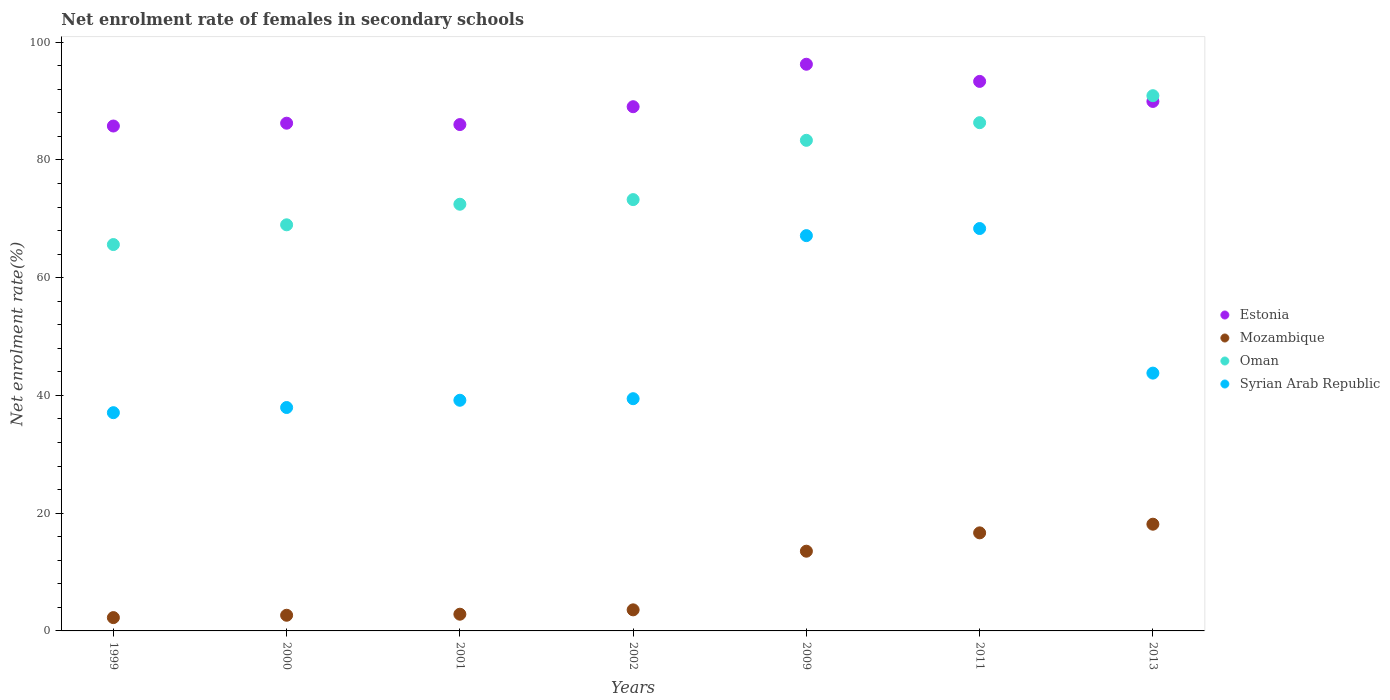Is the number of dotlines equal to the number of legend labels?
Keep it short and to the point. Yes. What is the net enrolment rate of females in secondary schools in Mozambique in 2011?
Offer a very short reply. 16.66. Across all years, what is the maximum net enrolment rate of females in secondary schools in Syrian Arab Republic?
Your answer should be compact. 68.35. Across all years, what is the minimum net enrolment rate of females in secondary schools in Oman?
Keep it short and to the point. 65.63. In which year was the net enrolment rate of females in secondary schools in Oman minimum?
Your answer should be very brief. 1999. What is the total net enrolment rate of females in secondary schools in Mozambique in the graph?
Your answer should be compact. 59.67. What is the difference between the net enrolment rate of females in secondary schools in Mozambique in 2000 and that in 2002?
Make the answer very short. -0.92. What is the difference between the net enrolment rate of females in secondary schools in Syrian Arab Republic in 2000 and the net enrolment rate of females in secondary schools in Mozambique in 2001?
Ensure brevity in your answer.  35.11. What is the average net enrolment rate of females in secondary schools in Estonia per year?
Provide a short and direct response. 89.51. In the year 1999, what is the difference between the net enrolment rate of females in secondary schools in Estonia and net enrolment rate of females in secondary schools in Syrian Arab Republic?
Keep it short and to the point. 48.69. What is the ratio of the net enrolment rate of females in secondary schools in Syrian Arab Republic in 1999 to that in 2002?
Ensure brevity in your answer.  0.94. Is the difference between the net enrolment rate of females in secondary schools in Estonia in 2000 and 2011 greater than the difference between the net enrolment rate of females in secondary schools in Syrian Arab Republic in 2000 and 2011?
Your response must be concise. Yes. What is the difference between the highest and the second highest net enrolment rate of females in secondary schools in Mozambique?
Give a very brief answer. 1.47. What is the difference between the highest and the lowest net enrolment rate of females in secondary schools in Oman?
Provide a short and direct response. 25.29. In how many years, is the net enrolment rate of females in secondary schools in Mozambique greater than the average net enrolment rate of females in secondary schools in Mozambique taken over all years?
Give a very brief answer. 3. Is the sum of the net enrolment rate of females in secondary schools in Mozambique in 2001 and 2009 greater than the maximum net enrolment rate of females in secondary schools in Estonia across all years?
Provide a succinct answer. No. Does the net enrolment rate of females in secondary schools in Mozambique monotonically increase over the years?
Provide a short and direct response. Yes. How many dotlines are there?
Keep it short and to the point. 4. What is the difference between two consecutive major ticks on the Y-axis?
Provide a succinct answer. 20. Does the graph contain any zero values?
Give a very brief answer. No. Does the graph contain grids?
Your response must be concise. No. What is the title of the graph?
Provide a short and direct response. Net enrolment rate of females in secondary schools. Does "Low income" appear as one of the legend labels in the graph?
Provide a succinct answer. No. What is the label or title of the X-axis?
Your response must be concise. Years. What is the label or title of the Y-axis?
Keep it short and to the point. Net enrolment rate(%). What is the Net enrolment rate(%) of Estonia in 1999?
Provide a succinct answer. 85.76. What is the Net enrolment rate(%) in Mozambique in 1999?
Give a very brief answer. 2.26. What is the Net enrolment rate(%) in Oman in 1999?
Give a very brief answer. 65.63. What is the Net enrolment rate(%) of Syrian Arab Republic in 1999?
Give a very brief answer. 37.07. What is the Net enrolment rate(%) of Estonia in 2000?
Give a very brief answer. 86.24. What is the Net enrolment rate(%) in Mozambique in 2000?
Keep it short and to the point. 2.66. What is the Net enrolment rate(%) in Oman in 2000?
Ensure brevity in your answer.  68.98. What is the Net enrolment rate(%) in Syrian Arab Republic in 2000?
Your answer should be very brief. 37.95. What is the Net enrolment rate(%) in Estonia in 2001?
Ensure brevity in your answer.  86.01. What is the Net enrolment rate(%) of Mozambique in 2001?
Your answer should be very brief. 2.84. What is the Net enrolment rate(%) of Oman in 2001?
Your answer should be compact. 72.48. What is the Net enrolment rate(%) of Syrian Arab Republic in 2001?
Your response must be concise. 39.18. What is the Net enrolment rate(%) in Estonia in 2002?
Make the answer very short. 89.04. What is the Net enrolment rate(%) in Mozambique in 2002?
Offer a very short reply. 3.58. What is the Net enrolment rate(%) of Oman in 2002?
Provide a succinct answer. 73.26. What is the Net enrolment rate(%) in Syrian Arab Republic in 2002?
Your answer should be very brief. 39.45. What is the Net enrolment rate(%) of Estonia in 2009?
Offer a very short reply. 96.26. What is the Net enrolment rate(%) in Mozambique in 2009?
Provide a short and direct response. 13.54. What is the Net enrolment rate(%) in Oman in 2009?
Keep it short and to the point. 83.33. What is the Net enrolment rate(%) of Syrian Arab Republic in 2009?
Offer a terse response. 67.14. What is the Net enrolment rate(%) of Estonia in 2011?
Ensure brevity in your answer.  93.34. What is the Net enrolment rate(%) in Mozambique in 2011?
Your response must be concise. 16.66. What is the Net enrolment rate(%) in Oman in 2011?
Ensure brevity in your answer.  86.33. What is the Net enrolment rate(%) of Syrian Arab Republic in 2011?
Your answer should be very brief. 68.35. What is the Net enrolment rate(%) in Estonia in 2013?
Offer a terse response. 89.94. What is the Net enrolment rate(%) in Mozambique in 2013?
Provide a short and direct response. 18.13. What is the Net enrolment rate(%) of Oman in 2013?
Offer a terse response. 90.91. What is the Net enrolment rate(%) in Syrian Arab Republic in 2013?
Ensure brevity in your answer.  43.79. Across all years, what is the maximum Net enrolment rate(%) in Estonia?
Offer a very short reply. 96.26. Across all years, what is the maximum Net enrolment rate(%) in Mozambique?
Give a very brief answer. 18.13. Across all years, what is the maximum Net enrolment rate(%) in Oman?
Your response must be concise. 90.91. Across all years, what is the maximum Net enrolment rate(%) of Syrian Arab Republic?
Give a very brief answer. 68.35. Across all years, what is the minimum Net enrolment rate(%) of Estonia?
Offer a very short reply. 85.76. Across all years, what is the minimum Net enrolment rate(%) in Mozambique?
Your answer should be compact. 2.26. Across all years, what is the minimum Net enrolment rate(%) in Oman?
Ensure brevity in your answer.  65.63. Across all years, what is the minimum Net enrolment rate(%) of Syrian Arab Republic?
Offer a very short reply. 37.07. What is the total Net enrolment rate(%) of Estonia in the graph?
Give a very brief answer. 626.59. What is the total Net enrolment rate(%) in Mozambique in the graph?
Provide a succinct answer. 59.67. What is the total Net enrolment rate(%) in Oman in the graph?
Make the answer very short. 540.92. What is the total Net enrolment rate(%) of Syrian Arab Republic in the graph?
Your answer should be very brief. 332.93. What is the difference between the Net enrolment rate(%) in Estonia in 1999 and that in 2000?
Provide a succinct answer. -0.48. What is the difference between the Net enrolment rate(%) in Mozambique in 1999 and that in 2000?
Your answer should be compact. -0.4. What is the difference between the Net enrolment rate(%) of Oman in 1999 and that in 2000?
Your response must be concise. -3.35. What is the difference between the Net enrolment rate(%) in Syrian Arab Republic in 1999 and that in 2000?
Ensure brevity in your answer.  -0.88. What is the difference between the Net enrolment rate(%) in Estonia in 1999 and that in 2001?
Keep it short and to the point. -0.25. What is the difference between the Net enrolment rate(%) of Mozambique in 1999 and that in 2001?
Provide a short and direct response. -0.58. What is the difference between the Net enrolment rate(%) of Oman in 1999 and that in 2001?
Provide a short and direct response. -6.85. What is the difference between the Net enrolment rate(%) of Syrian Arab Republic in 1999 and that in 2001?
Your answer should be compact. -2.11. What is the difference between the Net enrolment rate(%) in Estonia in 1999 and that in 2002?
Your answer should be very brief. -3.28. What is the difference between the Net enrolment rate(%) in Mozambique in 1999 and that in 2002?
Provide a short and direct response. -1.32. What is the difference between the Net enrolment rate(%) in Oman in 1999 and that in 2002?
Offer a very short reply. -7.64. What is the difference between the Net enrolment rate(%) of Syrian Arab Republic in 1999 and that in 2002?
Offer a terse response. -2.38. What is the difference between the Net enrolment rate(%) in Estonia in 1999 and that in 2009?
Your response must be concise. -10.49. What is the difference between the Net enrolment rate(%) in Mozambique in 1999 and that in 2009?
Provide a succinct answer. -11.28. What is the difference between the Net enrolment rate(%) of Oman in 1999 and that in 2009?
Your answer should be very brief. -17.71. What is the difference between the Net enrolment rate(%) of Syrian Arab Republic in 1999 and that in 2009?
Keep it short and to the point. -30.07. What is the difference between the Net enrolment rate(%) in Estonia in 1999 and that in 2011?
Make the answer very short. -7.58. What is the difference between the Net enrolment rate(%) of Mozambique in 1999 and that in 2011?
Your response must be concise. -14.4. What is the difference between the Net enrolment rate(%) of Oman in 1999 and that in 2011?
Keep it short and to the point. -20.7. What is the difference between the Net enrolment rate(%) of Syrian Arab Republic in 1999 and that in 2011?
Ensure brevity in your answer.  -31.28. What is the difference between the Net enrolment rate(%) in Estonia in 1999 and that in 2013?
Offer a terse response. -4.17. What is the difference between the Net enrolment rate(%) in Mozambique in 1999 and that in 2013?
Provide a succinct answer. -15.87. What is the difference between the Net enrolment rate(%) in Oman in 1999 and that in 2013?
Offer a terse response. -25.29. What is the difference between the Net enrolment rate(%) of Syrian Arab Republic in 1999 and that in 2013?
Make the answer very short. -6.72. What is the difference between the Net enrolment rate(%) of Estonia in 2000 and that in 2001?
Keep it short and to the point. 0.23. What is the difference between the Net enrolment rate(%) in Mozambique in 2000 and that in 2001?
Ensure brevity in your answer.  -0.18. What is the difference between the Net enrolment rate(%) in Oman in 2000 and that in 2001?
Provide a succinct answer. -3.49. What is the difference between the Net enrolment rate(%) in Syrian Arab Republic in 2000 and that in 2001?
Your answer should be very brief. -1.23. What is the difference between the Net enrolment rate(%) in Estonia in 2000 and that in 2002?
Offer a very short reply. -2.8. What is the difference between the Net enrolment rate(%) in Mozambique in 2000 and that in 2002?
Ensure brevity in your answer.  -0.92. What is the difference between the Net enrolment rate(%) of Oman in 2000 and that in 2002?
Make the answer very short. -4.28. What is the difference between the Net enrolment rate(%) of Syrian Arab Republic in 2000 and that in 2002?
Keep it short and to the point. -1.5. What is the difference between the Net enrolment rate(%) of Estonia in 2000 and that in 2009?
Your answer should be very brief. -10.01. What is the difference between the Net enrolment rate(%) of Mozambique in 2000 and that in 2009?
Offer a terse response. -10.88. What is the difference between the Net enrolment rate(%) of Oman in 2000 and that in 2009?
Your response must be concise. -14.35. What is the difference between the Net enrolment rate(%) of Syrian Arab Republic in 2000 and that in 2009?
Provide a succinct answer. -29.2. What is the difference between the Net enrolment rate(%) in Estonia in 2000 and that in 2011?
Your answer should be very brief. -7.1. What is the difference between the Net enrolment rate(%) of Mozambique in 2000 and that in 2011?
Make the answer very short. -14. What is the difference between the Net enrolment rate(%) in Oman in 2000 and that in 2011?
Keep it short and to the point. -17.35. What is the difference between the Net enrolment rate(%) in Syrian Arab Republic in 2000 and that in 2011?
Provide a succinct answer. -30.4. What is the difference between the Net enrolment rate(%) of Estonia in 2000 and that in 2013?
Offer a terse response. -3.69. What is the difference between the Net enrolment rate(%) in Mozambique in 2000 and that in 2013?
Your response must be concise. -15.47. What is the difference between the Net enrolment rate(%) of Oman in 2000 and that in 2013?
Offer a very short reply. -21.93. What is the difference between the Net enrolment rate(%) of Syrian Arab Republic in 2000 and that in 2013?
Offer a terse response. -5.84. What is the difference between the Net enrolment rate(%) in Estonia in 2001 and that in 2002?
Offer a very short reply. -3.03. What is the difference between the Net enrolment rate(%) in Mozambique in 2001 and that in 2002?
Provide a short and direct response. -0.74. What is the difference between the Net enrolment rate(%) of Oman in 2001 and that in 2002?
Your response must be concise. -0.79. What is the difference between the Net enrolment rate(%) in Syrian Arab Republic in 2001 and that in 2002?
Your response must be concise. -0.27. What is the difference between the Net enrolment rate(%) in Estonia in 2001 and that in 2009?
Your answer should be compact. -10.25. What is the difference between the Net enrolment rate(%) in Mozambique in 2001 and that in 2009?
Ensure brevity in your answer.  -10.7. What is the difference between the Net enrolment rate(%) in Oman in 2001 and that in 2009?
Your response must be concise. -10.86. What is the difference between the Net enrolment rate(%) in Syrian Arab Republic in 2001 and that in 2009?
Make the answer very short. -27.97. What is the difference between the Net enrolment rate(%) in Estonia in 2001 and that in 2011?
Offer a very short reply. -7.33. What is the difference between the Net enrolment rate(%) of Mozambique in 2001 and that in 2011?
Offer a very short reply. -13.82. What is the difference between the Net enrolment rate(%) in Oman in 2001 and that in 2011?
Your answer should be very brief. -13.85. What is the difference between the Net enrolment rate(%) in Syrian Arab Republic in 2001 and that in 2011?
Your answer should be compact. -29.17. What is the difference between the Net enrolment rate(%) of Estonia in 2001 and that in 2013?
Provide a succinct answer. -3.93. What is the difference between the Net enrolment rate(%) of Mozambique in 2001 and that in 2013?
Make the answer very short. -15.29. What is the difference between the Net enrolment rate(%) of Oman in 2001 and that in 2013?
Provide a short and direct response. -18.44. What is the difference between the Net enrolment rate(%) of Syrian Arab Republic in 2001 and that in 2013?
Ensure brevity in your answer.  -4.61. What is the difference between the Net enrolment rate(%) in Estonia in 2002 and that in 2009?
Provide a short and direct response. -7.21. What is the difference between the Net enrolment rate(%) in Mozambique in 2002 and that in 2009?
Provide a succinct answer. -9.96. What is the difference between the Net enrolment rate(%) in Oman in 2002 and that in 2009?
Your response must be concise. -10.07. What is the difference between the Net enrolment rate(%) in Syrian Arab Republic in 2002 and that in 2009?
Your answer should be compact. -27.7. What is the difference between the Net enrolment rate(%) in Estonia in 2002 and that in 2011?
Keep it short and to the point. -4.3. What is the difference between the Net enrolment rate(%) of Mozambique in 2002 and that in 2011?
Provide a succinct answer. -13.08. What is the difference between the Net enrolment rate(%) of Oman in 2002 and that in 2011?
Provide a succinct answer. -13.07. What is the difference between the Net enrolment rate(%) in Syrian Arab Republic in 2002 and that in 2011?
Provide a short and direct response. -28.9. What is the difference between the Net enrolment rate(%) in Estonia in 2002 and that in 2013?
Provide a short and direct response. -0.89. What is the difference between the Net enrolment rate(%) in Mozambique in 2002 and that in 2013?
Provide a short and direct response. -14.55. What is the difference between the Net enrolment rate(%) of Oman in 2002 and that in 2013?
Your answer should be very brief. -17.65. What is the difference between the Net enrolment rate(%) of Syrian Arab Republic in 2002 and that in 2013?
Your response must be concise. -4.34. What is the difference between the Net enrolment rate(%) in Estonia in 2009 and that in 2011?
Your answer should be compact. 2.91. What is the difference between the Net enrolment rate(%) in Mozambique in 2009 and that in 2011?
Keep it short and to the point. -3.12. What is the difference between the Net enrolment rate(%) of Oman in 2009 and that in 2011?
Your answer should be compact. -3. What is the difference between the Net enrolment rate(%) of Syrian Arab Republic in 2009 and that in 2011?
Keep it short and to the point. -1.21. What is the difference between the Net enrolment rate(%) of Estonia in 2009 and that in 2013?
Provide a succinct answer. 6.32. What is the difference between the Net enrolment rate(%) of Mozambique in 2009 and that in 2013?
Make the answer very short. -4.59. What is the difference between the Net enrolment rate(%) in Oman in 2009 and that in 2013?
Offer a terse response. -7.58. What is the difference between the Net enrolment rate(%) in Syrian Arab Republic in 2009 and that in 2013?
Provide a succinct answer. 23.35. What is the difference between the Net enrolment rate(%) in Estonia in 2011 and that in 2013?
Provide a short and direct response. 3.4. What is the difference between the Net enrolment rate(%) of Mozambique in 2011 and that in 2013?
Offer a very short reply. -1.47. What is the difference between the Net enrolment rate(%) in Oman in 2011 and that in 2013?
Your response must be concise. -4.58. What is the difference between the Net enrolment rate(%) in Syrian Arab Republic in 2011 and that in 2013?
Offer a very short reply. 24.56. What is the difference between the Net enrolment rate(%) of Estonia in 1999 and the Net enrolment rate(%) of Mozambique in 2000?
Your response must be concise. 83.1. What is the difference between the Net enrolment rate(%) in Estonia in 1999 and the Net enrolment rate(%) in Oman in 2000?
Provide a succinct answer. 16.78. What is the difference between the Net enrolment rate(%) in Estonia in 1999 and the Net enrolment rate(%) in Syrian Arab Republic in 2000?
Provide a short and direct response. 47.82. What is the difference between the Net enrolment rate(%) in Mozambique in 1999 and the Net enrolment rate(%) in Oman in 2000?
Your response must be concise. -66.72. What is the difference between the Net enrolment rate(%) of Mozambique in 1999 and the Net enrolment rate(%) of Syrian Arab Republic in 2000?
Give a very brief answer. -35.69. What is the difference between the Net enrolment rate(%) in Oman in 1999 and the Net enrolment rate(%) in Syrian Arab Republic in 2000?
Keep it short and to the point. 27.68. What is the difference between the Net enrolment rate(%) in Estonia in 1999 and the Net enrolment rate(%) in Mozambique in 2001?
Keep it short and to the point. 82.92. What is the difference between the Net enrolment rate(%) in Estonia in 1999 and the Net enrolment rate(%) in Oman in 2001?
Offer a terse response. 13.29. What is the difference between the Net enrolment rate(%) in Estonia in 1999 and the Net enrolment rate(%) in Syrian Arab Republic in 2001?
Keep it short and to the point. 46.58. What is the difference between the Net enrolment rate(%) in Mozambique in 1999 and the Net enrolment rate(%) in Oman in 2001?
Your answer should be very brief. -70.21. What is the difference between the Net enrolment rate(%) in Mozambique in 1999 and the Net enrolment rate(%) in Syrian Arab Republic in 2001?
Provide a short and direct response. -36.92. What is the difference between the Net enrolment rate(%) of Oman in 1999 and the Net enrolment rate(%) of Syrian Arab Republic in 2001?
Offer a terse response. 26.45. What is the difference between the Net enrolment rate(%) in Estonia in 1999 and the Net enrolment rate(%) in Mozambique in 2002?
Provide a short and direct response. 82.18. What is the difference between the Net enrolment rate(%) of Estonia in 1999 and the Net enrolment rate(%) of Oman in 2002?
Give a very brief answer. 12.5. What is the difference between the Net enrolment rate(%) in Estonia in 1999 and the Net enrolment rate(%) in Syrian Arab Republic in 2002?
Your response must be concise. 46.32. What is the difference between the Net enrolment rate(%) of Mozambique in 1999 and the Net enrolment rate(%) of Oman in 2002?
Offer a very short reply. -71. What is the difference between the Net enrolment rate(%) in Mozambique in 1999 and the Net enrolment rate(%) in Syrian Arab Republic in 2002?
Provide a short and direct response. -37.18. What is the difference between the Net enrolment rate(%) of Oman in 1999 and the Net enrolment rate(%) of Syrian Arab Republic in 2002?
Give a very brief answer. 26.18. What is the difference between the Net enrolment rate(%) of Estonia in 1999 and the Net enrolment rate(%) of Mozambique in 2009?
Offer a very short reply. 72.22. What is the difference between the Net enrolment rate(%) of Estonia in 1999 and the Net enrolment rate(%) of Oman in 2009?
Give a very brief answer. 2.43. What is the difference between the Net enrolment rate(%) in Estonia in 1999 and the Net enrolment rate(%) in Syrian Arab Republic in 2009?
Your answer should be compact. 18.62. What is the difference between the Net enrolment rate(%) in Mozambique in 1999 and the Net enrolment rate(%) in Oman in 2009?
Offer a very short reply. -81.07. What is the difference between the Net enrolment rate(%) in Mozambique in 1999 and the Net enrolment rate(%) in Syrian Arab Republic in 2009?
Give a very brief answer. -64.88. What is the difference between the Net enrolment rate(%) of Oman in 1999 and the Net enrolment rate(%) of Syrian Arab Republic in 2009?
Ensure brevity in your answer.  -1.52. What is the difference between the Net enrolment rate(%) of Estonia in 1999 and the Net enrolment rate(%) of Mozambique in 2011?
Keep it short and to the point. 69.11. What is the difference between the Net enrolment rate(%) in Estonia in 1999 and the Net enrolment rate(%) in Oman in 2011?
Your answer should be compact. -0.57. What is the difference between the Net enrolment rate(%) of Estonia in 1999 and the Net enrolment rate(%) of Syrian Arab Republic in 2011?
Your answer should be very brief. 17.41. What is the difference between the Net enrolment rate(%) of Mozambique in 1999 and the Net enrolment rate(%) of Oman in 2011?
Give a very brief answer. -84.07. What is the difference between the Net enrolment rate(%) in Mozambique in 1999 and the Net enrolment rate(%) in Syrian Arab Republic in 2011?
Your answer should be compact. -66.09. What is the difference between the Net enrolment rate(%) in Oman in 1999 and the Net enrolment rate(%) in Syrian Arab Republic in 2011?
Offer a terse response. -2.72. What is the difference between the Net enrolment rate(%) of Estonia in 1999 and the Net enrolment rate(%) of Mozambique in 2013?
Keep it short and to the point. 67.64. What is the difference between the Net enrolment rate(%) in Estonia in 1999 and the Net enrolment rate(%) in Oman in 2013?
Give a very brief answer. -5.15. What is the difference between the Net enrolment rate(%) of Estonia in 1999 and the Net enrolment rate(%) of Syrian Arab Republic in 2013?
Your answer should be very brief. 41.97. What is the difference between the Net enrolment rate(%) of Mozambique in 1999 and the Net enrolment rate(%) of Oman in 2013?
Your answer should be compact. -88.65. What is the difference between the Net enrolment rate(%) of Mozambique in 1999 and the Net enrolment rate(%) of Syrian Arab Republic in 2013?
Provide a succinct answer. -41.53. What is the difference between the Net enrolment rate(%) in Oman in 1999 and the Net enrolment rate(%) in Syrian Arab Republic in 2013?
Ensure brevity in your answer.  21.84. What is the difference between the Net enrolment rate(%) in Estonia in 2000 and the Net enrolment rate(%) in Mozambique in 2001?
Make the answer very short. 83.4. What is the difference between the Net enrolment rate(%) in Estonia in 2000 and the Net enrolment rate(%) in Oman in 2001?
Provide a short and direct response. 13.77. What is the difference between the Net enrolment rate(%) in Estonia in 2000 and the Net enrolment rate(%) in Syrian Arab Republic in 2001?
Your answer should be compact. 47.06. What is the difference between the Net enrolment rate(%) of Mozambique in 2000 and the Net enrolment rate(%) of Oman in 2001?
Ensure brevity in your answer.  -69.81. What is the difference between the Net enrolment rate(%) in Mozambique in 2000 and the Net enrolment rate(%) in Syrian Arab Republic in 2001?
Give a very brief answer. -36.52. What is the difference between the Net enrolment rate(%) in Oman in 2000 and the Net enrolment rate(%) in Syrian Arab Republic in 2001?
Give a very brief answer. 29.8. What is the difference between the Net enrolment rate(%) of Estonia in 2000 and the Net enrolment rate(%) of Mozambique in 2002?
Your response must be concise. 82.66. What is the difference between the Net enrolment rate(%) in Estonia in 2000 and the Net enrolment rate(%) in Oman in 2002?
Your answer should be very brief. 12.98. What is the difference between the Net enrolment rate(%) of Estonia in 2000 and the Net enrolment rate(%) of Syrian Arab Republic in 2002?
Your answer should be compact. 46.8. What is the difference between the Net enrolment rate(%) in Mozambique in 2000 and the Net enrolment rate(%) in Oman in 2002?
Your answer should be very brief. -70.6. What is the difference between the Net enrolment rate(%) in Mozambique in 2000 and the Net enrolment rate(%) in Syrian Arab Republic in 2002?
Give a very brief answer. -36.78. What is the difference between the Net enrolment rate(%) in Oman in 2000 and the Net enrolment rate(%) in Syrian Arab Republic in 2002?
Provide a short and direct response. 29.54. What is the difference between the Net enrolment rate(%) of Estonia in 2000 and the Net enrolment rate(%) of Mozambique in 2009?
Ensure brevity in your answer.  72.7. What is the difference between the Net enrolment rate(%) of Estonia in 2000 and the Net enrolment rate(%) of Oman in 2009?
Your answer should be compact. 2.91. What is the difference between the Net enrolment rate(%) of Estonia in 2000 and the Net enrolment rate(%) of Syrian Arab Republic in 2009?
Provide a succinct answer. 19.1. What is the difference between the Net enrolment rate(%) of Mozambique in 2000 and the Net enrolment rate(%) of Oman in 2009?
Offer a very short reply. -80.67. What is the difference between the Net enrolment rate(%) in Mozambique in 2000 and the Net enrolment rate(%) in Syrian Arab Republic in 2009?
Give a very brief answer. -64.48. What is the difference between the Net enrolment rate(%) of Oman in 2000 and the Net enrolment rate(%) of Syrian Arab Republic in 2009?
Your answer should be very brief. 1.84. What is the difference between the Net enrolment rate(%) of Estonia in 2000 and the Net enrolment rate(%) of Mozambique in 2011?
Give a very brief answer. 69.59. What is the difference between the Net enrolment rate(%) in Estonia in 2000 and the Net enrolment rate(%) in Oman in 2011?
Keep it short and to the point. -0.09. What is the difference between the Net enrolment rate(%) of Estonia in 2000 and the Net enrolment rate(%) of Syrian Arab Republic in 2011?
Your answer should be compact. 17.89. What is the difference between the Net enrolment rate(%) of Mozambique in 2000 and the Net enrolment rate(%) of Oman in 2011?
Your response must be concise. -83.67. What is the difference between the Net enrolment rate(%) in Mozambique in 2000 and the Net enrolment rate(%) in Syrian Arab Republic in 2011?
Your response must be concise. -65.69. What is the difference between the Net enrolment rate(%) of Oman in 2000 and the Net enrolment rate(%) of Syrian Arab Republic in 2011?
Offer a very short reply. 0.63. What is the difference between the Net enrolment rate(%) in Estonia in 2000 and the Net enrolment rate(%) in Mozambique in 2013?
Make the answer very short. 68.12. What is the difference between the Net enrolment rate(%) in Estonia in 2000 and the Net enrolment rate(%) in Oman in 2013?
Offer a very short reply. -4.67. What is the difference between the Net enrolment rate(%) in Estonia in 2000 and the Net enrolment rate(%) in Syrian Arab Republic in 2013?
Your response must be concise. 42.45. What is the difference between the Net enrolment rate(%) of Mozambique in 2000 and the Net enrolment rate(%) of Oman in 2013?
Provide a short and direct response. -88.25. What is the difference between the Net enrolment rate(%) in Mozambique in 2000 and the Net enrolment rate(%) in Syrian Arab Republic in 2013?
Offer a terse response. -41.13. What is the difference between the Net enrolment rate(%) of Oman in 2000 and the Net enrolment rate(%) of Syrian Arab Republic in 2013?
Offer a very short reply. 25.19. What is the difference between the Net enrolment rate(%) in Estonia in 2001 and the Net enrolment rate(%) in Mozambique in 2002?
Offer a terse response. 82.43. What is the difference between the Net enrolment rate(%) of Estonia in 2001 and the Net enrolment rate(%) of Oman in 2002?
Your response must be concise. 12.75. What is the difference between the Net enrolment rate(%) of Estonia in 2001 and the Net enrolment rate(%) of Syrian Arab Republic in 2002?
Your response must be concise. 46.56. What is the difference between the Net enrolment rate(%) of Mozambique in 2001 and the Net enrolment rate(%) of Oman in 2002?
Ensure brevity in your answer.  -70.42. What is the difference between the Net enrolment rate(%) of Mozambique in 2001 and the Net enrolment rate(%) of Syrian Arab Republic in 2002?
Ensure brevity in your answer.  -36.61. What is the difference between the Net enrolment rate(%) of Oman in 2001 and the Net enrolment rate(%) of Syrian Arab Republic in 2002?
Your answer should be compact. 33.03. What is the difference between the Net enrolment rate(%) of Estonia in 2001 and the Net enrolment rate(%) of Mozambique in 2009?
Ensure brevity in your answer.  72.47. What is the difference between the Net enrolment rate(%) of Estonia in 2001 and the Net enrolment rate(%) of Oman in 2009?
Make the answer very short. 2.68. What is the difference between the Net enrolment rate(%) of Estonia in 2001 and the Net enrolment rate(%) of Syrian Arab Republic in 2009?
Provide a succinct answer. 18.86. What is the difference between the Net enrolment rate(%) of Mozambique in 2001 and the Net enrolment rate(%) of Oman in 2009?
Offer a terse response. -80.49. What is the difference between the Net enrolment rate(%) in Mozambique in 2001 and the Net enrolment rate(%) in Syrian Arab Republic in 2009?
Offer a terse response. -64.31. What is the difference between the Net enrolment rate(%) in Oman in 2001 and the Net enrolment rate(%) in Syrian Arab Republic in 2009?
Keep it short and to the point. 5.33. What is the difference between the Net enrolment rate(%) of Estonia in 2001 and the Net enrolment rate(%) of Mozambique in 2011?
Your answer should be very brief. 69.35. What is the difference between the Net enrolment rate(%) in Estonia in 2001 and the Net enrolment rate(%) in Oman in 2011?
Make the answer very short. -0.32. What is the difference between the Net enrolment rate(%) of Estonia in 2001 and the Net enrolment rate(%) of Syrian Arab Republic in 2011?
Offer a terse response. 17.66. What is the difference between the Net enrolment rate(%) in Mozambique in 2001 and the Net enrolment rate(%) in Oman in 2011?
Keep it short and to the point. -83.49. What is the difference between the Net enrolment rate(%) of Mozambique in 2001 and the Net enrolment rate(%) of Syrian Arab Republic in 2011?
Offer a very short reply. -65.51. What is the difference between the Net enrolment rate(%) of Oman in 2001 and the Net enrolment rate(%) of Syrian Arab Republic in 2011?
Ensure brevity in your answer.  4.13. What is the difference between the Net enrolment rate(%) in Estonia in 2001 and the Net enrolment rate(%) in Mozambique in 2013?
Provide a short and direct response. 67.88. What is the difference between the Net enrolment rate(%) in Estonia in 2001 and the Net enrolment rate(%) in Oman in 2013?
Ensure brevity in your answer.  -4.9. What is the difference between the Net enrolment rate(%) in Estonia in 2001 and the Net enrolment rate(%) in Syrian Arab Republic in 2013?
Your answer should be compact. 42.22. What is the difference between the Net enrolment rate(%) of Mozambique in 2001 and the Net enrolment rate(%) of Oman in 2013?
Your response must be concise. -88.07. What is the difference between the Net enrolment rate(%) of Mozambique in 2001 and the Net enrolment rate(%) of Syrian Arab Republic in 2013?
Ensure brevity in your answer.  -40.95. What is the difference between the Net enrolment rate(%) of Oman in 2001 and the Net enrolment rate(%) of Syrian Arab Republic in 2013?
Provide a short and direct response. 28.69. What is the difference between the Net enrolment rate(%) in Estonia in 2002 and the Net enrolment rate(%) in Mozambique in 2009?
Keep it short and to the point. 75.5. What is the difference between the Net enrolment rate(%) in Estonia in 2002 and the Net enrolment rate(%) in Oman in 2009?
Provide a short and direct response. 5.71. What is the difference between the Net enrolment rate(%) of Estonia in 2002 and the Net enrolment rate(%) of Syrian Arab Republic in 2009?
Your answer should be very brief. 21.9. What is the difference between the Net enrolment rate(%) of Mozambique in 2002 and the Net enrolment rate(%) of Oman in 2009?
Provide a succinct answer. -79.75. What is the difference between the Net enrolment rate(%) of Mozambique in 2002 and the Net enrolment rate(%) of Syrian Arab Republic in 2009?
Your answer should be compact. -63.57. What is the difference between the Net enrolment rate(%) of Oman in 2002 and the Net enrolment rate(%) of Syrian Arab Republic in 2009?
Offer a very short reply. 6.12. What is the difference between the Net enrolment rate(%) in Estonia in 2002 and the Net enrolment rate(%) in Mozambique in 2011?
Give a very brief answer. 72.39. What is the difference between the Net enrolment rate(%) of Estonia in 2002 and the Net enrolment rate(%) of Oman in 2011?
Make the answer very short. 2.71. What is the difference between the Net enrolment rate(%) of Estonia in 2002 and the Net enrolment rate(%) of Syrian Arab Republic in 2011?
Provide a short and direct response. 20.69. What is the difference between the Net enrolment rate(%) of Mozambique in 2002 and the Net enrolment rate(%) of Oman in 2011?
Your answer should be very brief. -82.75. What is the difference between the Net enrolment rate(%) in Mozambique in 2002 and the Net enrolment rate(%) in Syrian Arab Republic in 2011?
Keep it short and to the point. -64.77. What is the difference between the Net enrolment rate(%) in Oman in 2002 and the Net enrolment rate(%) in Syrian Arab Republic in 2011?
Offer a terse response. 4.91. What is the difference between the Net enrolment rate(%) in Estonia in 2002 and the Net enrolment rate(%) in Mozambique in 2013?
Make the answer very short. 70.92. What is the difference between the Net enrolment rate(%) of Estonia in 2002 and the Net enrolment rate(%) of Oman in 2013?
Your answer should be compact. -1.87. What is the difference between the Net enrolment rate(%) in Estonia in 2002 and the Net enrolment rate(%) in Syrian Arab Republic in 2013?
Provide a succinct answer. 45.25. What is the difference between the Net enrolment rate(%) in Mozambique in 2002 and the Net enrolment rate(%) in Oman in 2013?
Your answer should be compact. -87.33. What is the difference between the Net enrolment rate(%) of Mozambique in 2002 and the Net enrolment rate(%) of Syrian Arab Republic in 2013?
Your answer should be compact. -40.21. What is the difference between the Net enrolment rate(%) of Oman in 2002 and the Net enrolment rate(%) of Syrian Arab Republic in 2013?
Offer a terse response. 29.47. What is the difference between the Net enrolment rate(%) in Estonia in 2009 and the Net enrolment rate(%) in Mozambique in 2011?
Make the answer very short. 79.6. What is the difference between the Net enrolment rate(%) of Estonia in 2009 and the Net enrolment rate(%) of Oman in 2011?
Ensure brevity in your answer.  9.93. What is the difference between the Net enrolment rate(%) of Estonia in 2009 and the Net enrolment rate(%) of Syrian Arab Republic in 2011?
Make the answer very short. 27.91. What is the difference between the Net enrolment rate(%) in Mozambique in 2009 and the Net enrolment rate(%) in Oman in 2011?
Your response must be concise. -72.79. What is the difference between the Net enrolment rate(%) in Mozambique in 2009 and the Net enrolment rate(%) in Syrian Arab Republic in 2011?
Offer a very short reply. -54.81. What is the difference between the Net enrolment rate(%) in Oman in 2009 and the Net enrolment rate(%) in Syrian Arab Republic in 2011?
Make the answer very short. 14.98. What is the difference between the Net enrolment rate(%) of Estonia in 2009 and the Net enrolment rate(%) of Mozambique in 2013?
Ensure brevity in your answer.  78.13. What is the difference between the Net enrolment rate(%) in Estonia in 2009 and the Net enrolment rate(%) in Oman in 2013?
Provide a short and direct response. 5.34. What is the difference between the Net enrolment rate(%) of Estonia in 2009 and the Net enrolment rate(%) of Syrian Arab Republic in 2013?
Offer a terse response. 52.46. What is the difference between the Net enrolment rate(%) of Mozambique in 2009 and the Net enrolment rate(%) of Oman in 2013?
Provide a succinct answer. -77.37. What is the difference between the Net enrolment rate(%) in Mozambique in 2009 and the Net enrolment rate(%) in Syrian Arab Republic in 2013?
Keep it short and to the point. -30.25. What is the difference between the Net enrolment rate(%) of Oman in 2009 and the Net enrolment rate(%) of Syrian Arab Republic in 2013?
Provide a succinct answer. 39.54. What is the difference between the Net enrolment rate(%) of Estonia in 2011 and the Net enrolment rate(%) of Mozambique in 2013?
Your answer should be very brief. 75.21. What is the difference between the Net enrolment rate(%) in Estonia in 2011 and the Net enrolment rate(%) in Oman in 2013?
Give a very brief answer. 2.43. What is the difference between the Net enrolment rate(%) of Estonia in 2011 and the Net enrolment rate(%) of Syrian Arab Republic in 2013?
Keep it short and to the point. 49.55. What is the difference between the Net enrolment rate(%) in Mozambique in 2011 and the Net enrolment rate(%) in Oman in 2013?
Offer a terse response. -74.26. What is the difference between the Net enrolment rate(%) in Mozambique in 2011 and the Net enrolment rate(%) in Syrian Arab Republic in 2013?
Your response must be concise. -27.13. What is the difference between the Net enrolment rate(%) of Oman in 2011 and the Net enrolment rate(%) of Syrian Arab Republic in 2013?
Keep it short and to the point. 42.54. What is the average Net enrolment rate(%) in Estonia per year?
Provide a succinct answer. 89.51. What is the average Net enrolment rate(%) in Mozambique per year?
Make the answer very short. 8.52. What is the average Net enrolment rate(%) of Oman per year?
Make the answer very short. 77.27. What is the average Net enrolment rate(%) of Syrian Arab Republic per year?
Provide a succinct answer. 47.56. In the year 1999, what is the difference between the Net enrolment rate(%) in Estonia and Net enrolment rate(%) in Mozambique?
Offer a very short reply. 83.5. In the year 1999, what is the difference between the Net enrolment rate(%) of Estonia and Net enrolment rate(%) of Oman?
Your answer should be very brief. 20.14. In the year 1999, what is the difference between the Net enrolment rate(%) of Estonia and Net enrolment rate(%) of Syrian Arab Republic?
Offer a very short reply. 48.69. In the year 1999, what is the difference between the Net enrolment rate(%) of Mozambique and Net enrolment rate(%) of Oman?
Offer a very short reply. -63.37. In the year 1999, what is the difference between the Net enrolment rate(%) of Mozambique and Net enrolment rate(%) of Syrian Arab Republic?
Your response must be concise. -34.81. In the year 1999, what is the difference between the Net enrolment rate(%) of Oman and Net enrolment rate(%) of Syrian Arab Republic?
Provide a short and direct response. 28.56. In the year 2000, what is the difference between the Net enrolment rate(%) in Estonia and Net enrolment rate(%) in Mozambique?
Make the answer very short. 83.58. In the year 2000, what is the difference between the Net enrolment rate(%) in Estonia and Net enrolment rate(%) in Oman?
Make the answer very short. 17.26. In the year 2000, what is the difference between the Net enrolment rate(%) in Estonia and Net enrolment rate(%) in Syrian Arab Republic?
Your answer should be very brief. 48.3. In the year 2000, what is the difference between the Net enrolment rate(%) of Mozambique and Net enrolment rate(%) of Oman?
Provide a short and direct response. -66.32. In the year 2000, what is the difference between the Net enrolment rate(%) in Mozambique and Net enrolment rate(%) in Syrian Arab Republic?
Your answer should be very brief. -35.29. In the year 2000, what is the difference between the Net enrolment rate(%) in Oman and Net enrolment rate(%) in Syrian Arab Republic?
Your response must be concise. 31.03. In the year 2001, what is the difference between the Net enrolment rate(%) in Estonia and Net enrolment rate(%) in Mozambique?
Provide a succinct answer. 83.17. In the year 2001, what is the difference between the Net enrolment rate(%) of Estonia and Net enrolment rate(%) of Oman?
Your response must be concise. 13.53. In the year 2001, what is the difference between the Net enrolment rate(%) of Estonia and Net enrolment rate(%) of Syrian Arab Republic?
Provide a short and direct response. 46.83. In the year 2001, what is the difference between the Net enrolment rate(%) of Mozambique and Net enrolment rate(%) of Oman?
Your response must be concise. -69.64. In the year 2001, what is the difference between the Net enrolment rate(%) of Mozambique and Net enrolment rate(%) of Syrian Arab Republic?
Offer a terse response. -36.34. In the year 2001, what is the difference between the Net enrolment rate(%) of Oman and Net enrolment rate(%) of Syrian Arab Republic?
Ensure brevity in your answer.  33.3. In the year 2002, what is the difference between the Net enrolment rate(%) in Estonia and Net enrolment rate(%) in Mozambique?
Offer a very short reply. 85.46. In the year 2002, what is the difference between the Net enrolment rate(%) in Estonia and Net enrolment rate(%) in Oman?
Your response must be concise. 15.78. In the year 2002, what is the difference between the Net enrolment rate(%) in Estonia and Net enrolment rate(%) in Syrian Arab Republic?
Your response must be concise. 49.6. In the year 2002, what is the difference between the Net enrolment rate(%) of Mozambique and Net enrolment rate(%) of Oman?
Your response must be concise. -69.68. In the year 2002, what is the difference between the Net enrolment rate(%) in Mozambique and Net enrolment rate(%) in Syrian Arab Republic?
Your answer should be compact. -35.87. In the year 2002, what is the difference between the Net enrolment rate(%) in Oman and Net enrolment rate(%) in Syrian Arab Republic?
Make the answer very short. 33.82. In the year 2009, what is the difference between the Net enrolment rate(%) in Estonia and Net enrolment rate(%) in Mozambique?
Provide a short and direct response. 82.71. In the year 2009, what is the difference between the Net enrolment rate(%) in Estonia and Net enrolment rate(%) in Oman?
Ensure brevity in your answer.  12.92. In the year 2009, what is the difference between the Net enrolment rate(%) in Estonia and Net enrolment rate(%) in Syrian Arab Republic?
Provide a succinct answer. 29.11. In the year 2009, what is the difference between the Net enrolment rate(%) of Mozambique and Net enrolment rate(%) of Oman?
Provide a short and direct response. -69.79. In the year 2009, what is the difference between the Net enrolment rate(%) of Mozambique and Net enrolment rate(%) of Syrian Arab Republic?
Your answer should be compact. -53.6. In the year 2009, what is the difference between the Net enrolment rate(%) in Oman and Net enrolment rate(%) in Syrian Arab Republic?
Offer a very short reply. 16.19. In the year 2011, what is the difference between the Net enrolment rate(%) in Estonia and Net enrolment rate(%) in Mozambique?
Offer a terse response. 76.68. In the year 2011, what is the difference between the Net enrolment rate(%) of Estonia and Net enrolment rate(%) of Oman?
Your answer should be very brief. 7.01. In the year 2011, what is the difference between the Net enrolment rate(%) in Estonia and Net enrolment rate(%) in Syrian Arab Republic?
Offer a terse response. 24.99. In the year 2011, what is the difference between the Net enrolment rate(%) of Mozambique and Net enrolment rate(%) of Oman?
Keep it short and to the point. -69.67. In the year 2011, what is the difference between the Net enrolment rate(%) of Mozambique and Net enrolment rate(%) of Syrian Arab Republic?
Offer a terse response. -51.69. In the year 2011, what is the difference between the Net enrolment rate(%) in Oman and Net enrolment rate(%) in Syrian Arab Republic?
Provide a succinct answer. 17.98. In the year 2013, what is the difference between the Net enrolment rate(%) in Estonia and Net enrolment rate(%) in Mozambique?
Offer a terse response. 71.81. In the year 2013, what is the difference between the Net enrolment rate(%) of Estonia and Net enrolment rate(%) of Oman?
Keep it short and to the point. -0.98. In the year 2013, what is the difference between the Net enrolment rate(%) in Estonia and Net enrolment rate(%) in Syrian Arab Republic?
Provide a succinct answer. 46.15. In the year 2013, what is the difference between the Net enrolment rate(%) in Mozambique and Net enrolment rate(%) in Oman?
Provide a short and direct response. -72.78. In the year 2013, what is the difference between the Net enrolment rate(%) of Mozambique and Net enrolment rate(%) of Syrian Arab Republic?
Offer a very short reply. -25.66. In the year 2013, what is the difference between the Net enrolment rate(%) in Oman and Net enrolment rate(%) in Syrian Arab Republic?
Make the answer very short. 47.12. What is the ratio of the Net enrolment rate(%) of Mozambique in 1999 to that in 2000?
Offer a very short reply. 0.85. What is the ratio of the Net enrolment rate(%) of Oman in 1999 to that in 2000?
Your answer should be compact. 0.95. What is the ratio of the Net enrolment rate(%) in Syrian Arab Republic in 1999 to that in 2000?
Provide a short and direct response. 0.98. What is the ratio of the Net enrolment rate(%) in Mozambique in 1999 to that in 2001?
Your response must be concise. 0.8. What is the ratio of the Net enrolment rate(%) of Oman in 1999 to that in 2001?
Offer a very short reply. 0.91. What is the ratio of the Net enrolment rate(%) of Syrian Arab Republic in 1999 to that in 2001?
Give a very brief answer. 0.95. What is the ratio of the Net enrolment rate(%) of Estonia in 1999 to that in 2002?
Offer a very short reply. 0.96. What is the ratio of the Net enrolment rate(%) in Mozambique in 1999 to that in 2002?
Your response must be concise. 0.63. What is the ratio of the Net enrolment rate(%) of Oman in 1999 to that in 2002?
Provide a short and direct response. 0.9. What is the ratio of the Net enrolment rate(%) of Syrian Arab Republic in 1999 to that in 2002?
Your answer should be compact. 0.94. What is the ratio of the Net enrolment rate(%) of Estonia in 1999 to that in 2009?
Your answer should be very brief. 0.89. What is the ratio of the Net enrolment rate(%) of Mozambique in 1999 to that in 2009?
Your response must be concise. 0.17. What is the ratio of the Net enrolment rate(%) of Oman in 1999 to that in 2009?
Offer a terse response. 0.79. What is the ratio of the Net enrolment rate(%) in Syrian Arab Republic in 1999 to that in 2009?
Your response must be concise. 0.55. What is the ratio of the Net enrolment rate(%) in Estonia in 1999 to that in 2011?
Make the answer very short. 0.92. What is the ratio of the Net enrolment rate(%) in Mozambique in 1999 to that in 2011?
Give a very brief answer. 0.14. What is the ratio of the Net enrolment rate(%) of Oman in 1999 to that in 2011?
Your answer should be compact. 0.76. What is the ratio of the Net enrolment rate(%) of Syrian Arab Republic in 1999 to that in 2011?
Give a very brief answer. 0.54. What is the ratio of the Net enrolment rate(%) of Estonia in 1999 to that in 2013?
Offer a very short reply. 0.95. What is the ratio of the Net enrolment rate(%) in Mozambique in 1999 to that in 2013?
Give a very brief answer. 0.12. What is the ratio of the Net enrolment rate(%) in Oman in 1999 to that in 2013?
Offer a terse response. 0.72. What is the ratio of the Net enrolment rate(%) of Syrian Arab Republic in 1999 to that in 2013?
Ensure brevity in your answer.  0.85. What is the ratio of the Net enrolment rate(%) in Mozambique in 2000 to that in 2001?
Keep it short and to the point. 0.94. What is the ratio of the Net enrolment rate(%) in Oman in 2000 to that in 2001?
Make the answer very short. 0.95. What is the ratio of the Net enrolment rate(%) in Syrian Arab Republic in 2000 to that in 2001?
Offer a very short reply. 0.97. What is the ratio of the Net enrolment rate(%) of Estonia in 2000 to that in 2002?
Provide a short and direct response. 0.97. What is the ratio of the Net enrolment rate(%) in Mozambique in 2000 to that in 2002?
Your answer should be compact. 0.74. What is the ratio of the Net enrolment rate(%) in Oman in 2000 to that in 2002?
Ensure brevity in your answer.  0.94. What is the ratio of the Net enrolment rate(%) of Syrian Arab Republic in 2000 to that in 2002?
Ensure brevity in your answer.  0.96. What is the ratio of the Net enrolment rate(%) of Estonia in 2000 to that in 2009?
Make the answer very short. 0.9. What is the ratio of the Net enrolment rate(%) in Mozambique in 2000 to that in 2009?
Offer a terse response. 0.2. What is the ratio of the Net enrolment rate(%) of Oman in 2000 to that in 2009?
Offer a very short reply. 0.83. What is the ratio of the Net enrolment rate(%) of Syrian Arab Republic in 2000 to that in 2009?
Offer a very short reply. 0.57. What is the ratio of the Net enrolment rate(%) of Estonia in 2000 to that in 2011?
Keep it short and to the point. 0.92. What is the ratio of the Net enrolment rate(%) in Mozambique in 2000 to that in 2011?
Offer a terse response. 0.16. What is the ratio of the Net enrolment rate(%) in Oman in 2000 to that in 2011?
Offer a very short reply. 0.8. What is the ratio of the Net enrolment rate(%) of Syrian Arab Republic in 2000 to that in 2011?
Keep it short and to the point. 0.56. What is the ratio of the Net enrolment rate(%) in Estonia in 2000 to that in 2013?
Offer a very short reply. 0.96. What is the ratio of the Net enrolment rate(%) of Mozambique in 2000 to that in 2013?
Your response must be concise. 0.15. What is the ratio of the Net enrolment rate(%) in Oman in 2000 to that in 2013?
Your response must be concise. 0.76. What is the ratio of the Net enrolment rate(%) in Syrian Arab Republic in 2000 to that in 2013?
Provide a short and direct response. 0.87. What is the ratio of the Net enrolment rate(%) of Estonia in 2001 to that in 2002?
Ensure brevity in your answer.  0.97. What is the ratio of the Net enrolment rate(%) of Mozambique in 2001 to that in 2002?
Give a very brief answer. 0.79. What is the ratio of the Net enrolment rate(%) in Oman in 2001 to that in 2002?
Your response must be concise. 0.99. What is the ratio of the Net enrolment rate(%) in Estonia in 2001 to that in 2009?
Provide a succinct answer. 0.89. What is the ratio of the Net enrolment rate(%) in Mozambique in 2001 to that in 2009?
Offer a terse response. 0.21. What is the ratio of the Net enrolment rate(%) of Oman in 2001 to that in 2009?
Your answer should be very brief. 0.87. What is the ratio of the Net enrolment rate(%) of Syrian Arab Republic in 2001 to that in 2009?
Provide a succinct answer. 0.58. What is the ratio of the Net enrolment rate(%) of Estonia in 2001 to that in 2011?
Provide a short and direct response. 0.92. What is the ratio of the Net enrolment rate(%) of Mozambique in 2001 to that in 2011?
Your answer should be very brief. 0.17. What is the ratio of the Net enrolment rate(%) of Oman in 2001 to that in 2011?
Make the answer very short. 0.84. What is the ratio of the Net enrolment rate(%) of Syrian Arab Republic in 2001 to that in 2011?
Offer a very short reply. 0.57. What is the ratio of the Net enrolment rate(%) of Estonia in 2001 to that in 2013?
Give a very brief answer. 0.96. What is the ratio of the Net enrolment rate(%) of Mozambique in 2001 to that in 2013?
Make the answer very short. 0.16. What is the ratio of the Net enrolment rate(%) in Oman in 2001 to that in 2013?
Provide a succinct answer. 0.8. What is the ratio of the Net enrolment rate(%) in Syrian Arab Republic in 2001 to that in 2013?
Your answer should be very brief. 0.89. What is the ratio of the Net enrolment rate(%) of Estonia in 2002 to that in 2009?
Offer a very short reply. 0.93. What is the ratio of the Net enrolment rate(%) of Mozambique in 2002 to that in 2009?
Your response must be concise. 0.26. What is the ratio of the Net enrolment rate(%) of Oman in 2002 to that in 2009?
Make the answer very short. 0.88. What is the ratio of the Net enrolment rate(%) in Syrian Arab Republic in 2002 to that in 2009?
Ensure brevity in your answer.  0.59. What is the ratio of the Net enrolment rate(%) of Estonia in 2002 to that in 2011?
Give a very brief answer. 0.95. What is the ratio of the Net enrolment rate(%) in Mozambique in 2002 to that in 2011?
Your answer should be compact. 0.21. What is the ratio of the Net enrolment rate(%) of Oman in 2002 to that in 2011?
Your answer should be compact. 0.85. What is the ratio of the Net enrolment rate(%) in Syrian Arab Republic in 2002 to that in 2011?
Your response must be concise. 0.58. What is the ratio of the Net enrolment rate(%) of Mozambique in 2002 to that in 2013?
Provide a short and direct response. 0.2. What is the ratio of the Net enrolment rate(%) of Oman in 2002 to that in 2013?
Make the answer very short. 0.81. What is the ratio of the Net enrolment rate(%) of Syrian Arab Republic in 2002 to that in 2013?
Ensure brevity in your answer.  0.9. What is the ratio of the Net enrolment rate(%) of Estonia in 2009 to that in 2011?
Your answer should be compact. 1.03. What is the ratio of the Net enrolment rate(%) of Mozambique in 2009 to that in 2011?
Keep it short and to the point. 0.81. What is the ratio of the Net enrolment rate(%) of Oman in 2009 to that in 2011?
Your response must be concise. 0.97. What is the ratio of the Net enrolment rate(%) of Syrian Arab Republic in 2009 to that in 2011?
Your answer should be compact. 0.98. What is the ratio of the Net enrolment rate(%) of Estonia in 2009 to that in 2013?
Your answer should be compact. 1.07. What is the ratio of the Net enrolment rate(%) in Mozambique in 2009 to that in 2013?
Provide a short and direct response. 0.75. What is the ratio of the Net enrolment rate(%) of Oman in 2009 to that in 2013?
Offer a terse response. 0.92. What is the ratio of the Net enrolment rate(%) in Syrian Arab Republic in 2009 to that in 2013?
Provide a short and direct response. 1.53. What is the ratio of the Net enrolment rate(%) in Estonia in 2011 to that in 2013?
Your response must be concise. 1.04. What is the ratio of the Net enrolment rate(%) in Mozambique in 2011 to that in 2013?
Keep it short and to the point. 0.92. What is the ratio of the Net enrolment rate(%) in Oman in 2011 to that in 2013?
Provide a short and direct response. 0.95. What is the ratio of the Net enrolment rate(%) in Syrian Arab Republic in 2011 to that in 2013?
Make the answer very short. 1.56. What is the difference between the highest and the second highest Net enrolment rate(%) in Estonia?
Offer a terse response. 2.91. What is the difference between the highest and the second highest Net enrolment rate(%) in Mozambique?
Provide a succinct answer. 1.47. What is the difference between the highest and the second highest Net enrolment rate(%) in Oman?
Provide a succinct answer. 4.58. What is the difference between the highest and the second highest Net enrolment rate(%) in Syrian Arab Republic?
Ensure brevity in your answer.  1.21. What is the difference between the highest and the lowest Net enrolment rate(%) in Estonia?
Your answer should be very brief. 10.49. What is the difference between the highest and the lowest Net enrolment rate(%) in Mozambique?
Provide a short and direct response. 15.87. What is the difference between the highest and the lowest Net enrolment rate(%) in Oman?
Offer a terse response. 25.29. What is the difference between the highest and the lowest Net enrolment rate(%) of Syrian Arab Republic?
Your answer should be very brief. 31.28. 